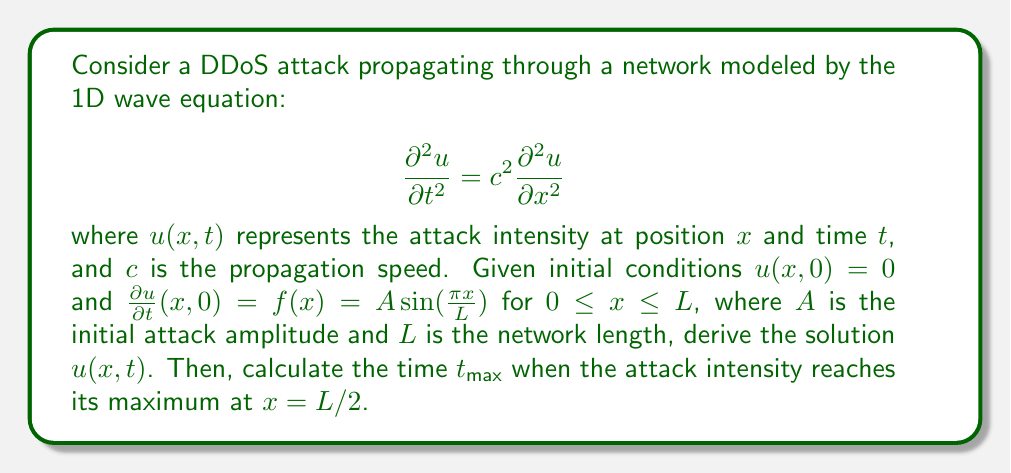Show me your answer to this math problem. 1) The general solution to the 1D wave equation is given by D'Alembert's formula:

   $$u(x,t) = \frac{1}{2}[F(x+ct) + F(x-ct)] + \frac{1}{2c}\int_{x-ct}^{x+ct} f(s)ds$$

   where $F(x)$ is determined by the initial displacement.

2) Given $u(x,0) = 0$, we have $F(x) = 0$. The solution simplifies to:

   $$u(x,t) = \frac{1}{2c}\int_{x-ct}^{x+ct} f(s)ds$$

3) Substituting $f(x) = A\sin(\frac{\pi x}{L})$:

   $$u(x,t) = \frac{A}{2c}\int_{x-ct}^{x+ct} \sin(\frac{\pi s}{L})ds$$

4) Evaluating the integral:

   $$u(x,t) = \frac{AL}{\pi c}\left[\cos(\frac{\pi(x-ct)}{L}) - \cos(\frac{\pi(x+ct)}{L})\right]$$

5) Using the trigonometric identity $\cos A - \cos B = -2\sin(\frac{A+B}{2})\sin(\frac{A-B}{2})$:

   $$u(x,t) = \frac{2AL}{\pi c}\sin(\frac{\pi x}{L})\sin(\frac{\pi ct}{L})$$

6) To find $t_{\text{max}}$ at $x = L/2$, we need to maximize:

   $$u(L/2,t) = \frac{2AL}{\pi c}\sin(\frac{\pi}{2})\sin(\frac{\pi ct}{L}) = \frac{2AL}{\pi c}\sin(\frac{\pi ct}{L})$$

7) This function reaches its maximum when $\sin(\frac{\pi ct}{L}) = 1$, which occurs when:

   $$\frac{\pi ct}{L} = \frac{\pi}{2} + n\pi, \quad n = 0,1,2,...$$

8) The first maximum (n = 0) occurs at:

   $$t_{\text{max}} = \frac{L}{2c}$$
Answer: $t_{\text{max}} = \frac{L}{2c}$ 